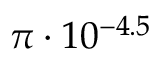<formula> <loc_0><loc_0><loc_500><loc_500>\pi \cdot 1 0 ^ { - 4 . 5 }</formula> 